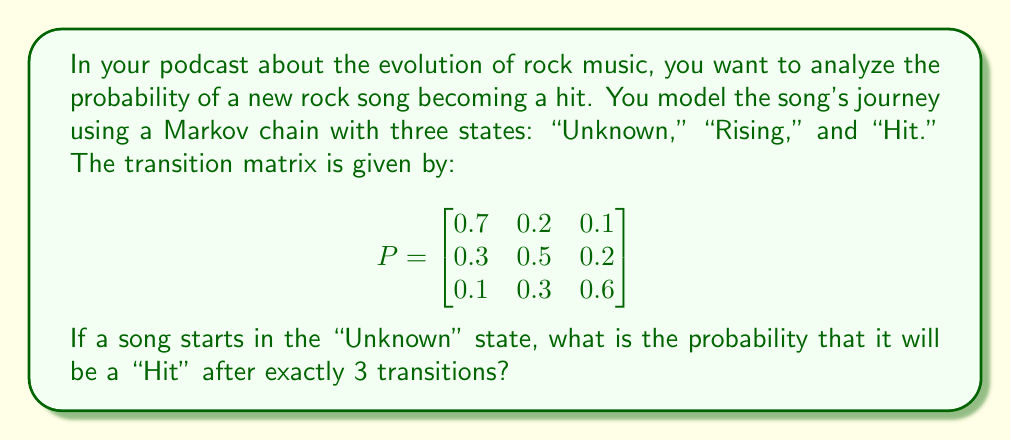Solve this math problem. To solve this problem, we need to use the Chapman-Kolmogorov equations and matrix multiplication. Let's break it down step-by-step:

1) We want to find the probability of being in the "Hit" state after 3 transitions, starting from the "Unknown" state. This is equivalent to calculating the element in the first row, third column of $P^3$.

2) To calculate $P^3$, we need to multiply $P$ by itself three times:

   $P^3 = P \times P \times P$

3) Let's calculate $P^2$ first:

   $$P^2 = \begin{bmatrix}
   0.7 & 0.2 & 0.1 \\
   0.3 & 0.5 & 0.2 \\
   0.1 & 0.3 & 0.6
   \end{bmatrix} \times \begin{bmatrix}
   0.7 & 0.2 & 0.1 \\
   0.3 & 0.5 & 0.2 \\
   0.1 & 0.3 & 0.6
   \end{bmatrix}$$

   $$P^2 = \begin{bmatrix}
   0.56 & 0.29 & 0.15 \\
   0.40 & 0.41 & 0.19 \\
   0.22 & 0.36 & 0.42
   \end{bmatrix}$$

4) Now we can calculate $P^3$:

   $$P^3 = P^2 \times P = \begin{bmatrix}
   0.56 & 0.29 & 0.15 \\
   0.40 & 0.41 & 0.19 \\
   0.22 & 0.36 & 0.42
   \end{bmatrix} \times \begin{bmatrix}
   0.7 & 0.2 & 0.1 \\
   0.3 & 0.5 & 0.2 \\
   0.1 & 0.3 & 0.6
   \end{bmatrix}$$

   $$P^3 = \begin{bmatrix}
   0.497 & 0.317 & 0.186 \\
   0.421 & 0.382 & 0.197 \\
   0.295 & 0.389 & 0.316
   \end{bmatrix}$$

5) The probability we're looking for is the element in the first row, third column of $P^3$, which is 0.186.

Therefore, the probability that a song starting in the "Unknown" state will be a "Hit" after exactly 3 transitions is 0.186 or 18.6%.
Answer: 0.186 